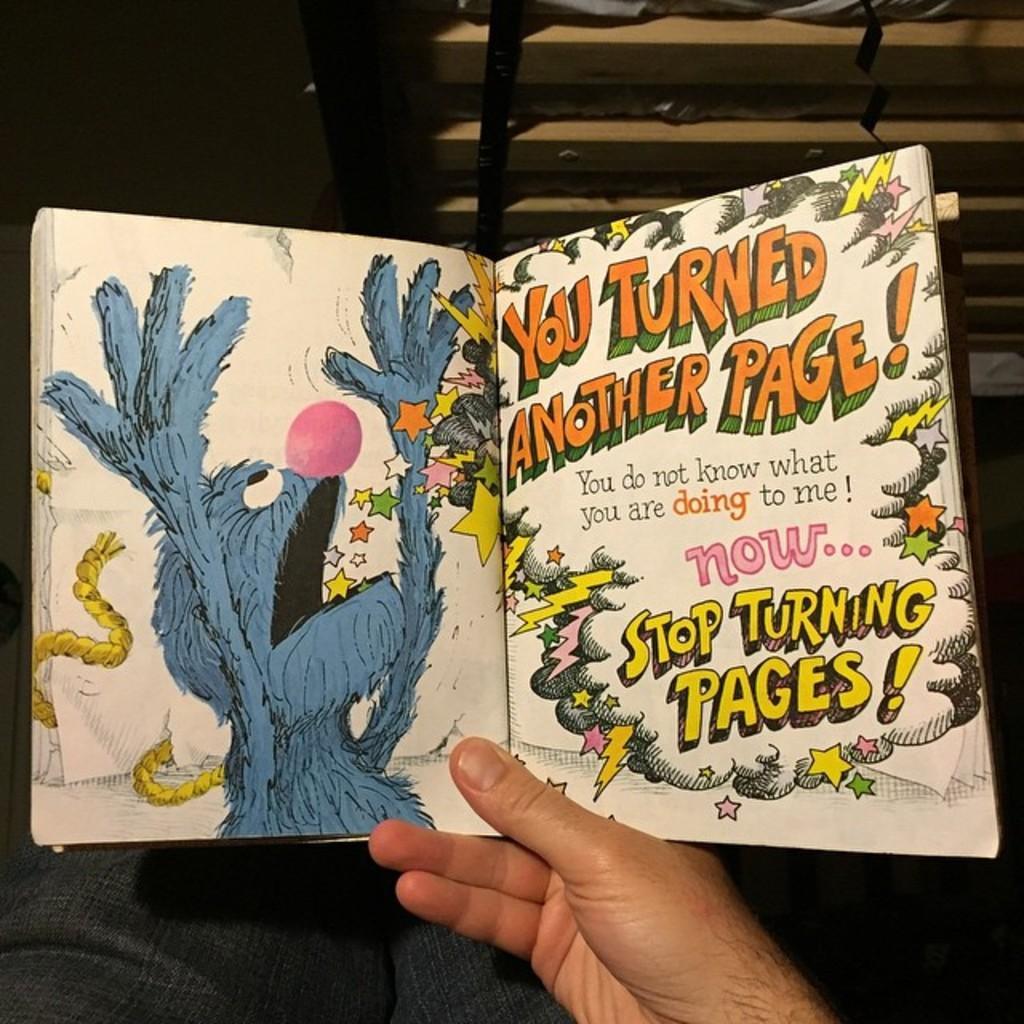Can you describe this image briefly? In the image there is a person holding a book with his hand and only the hand and the legs of the person are visible in the image. 